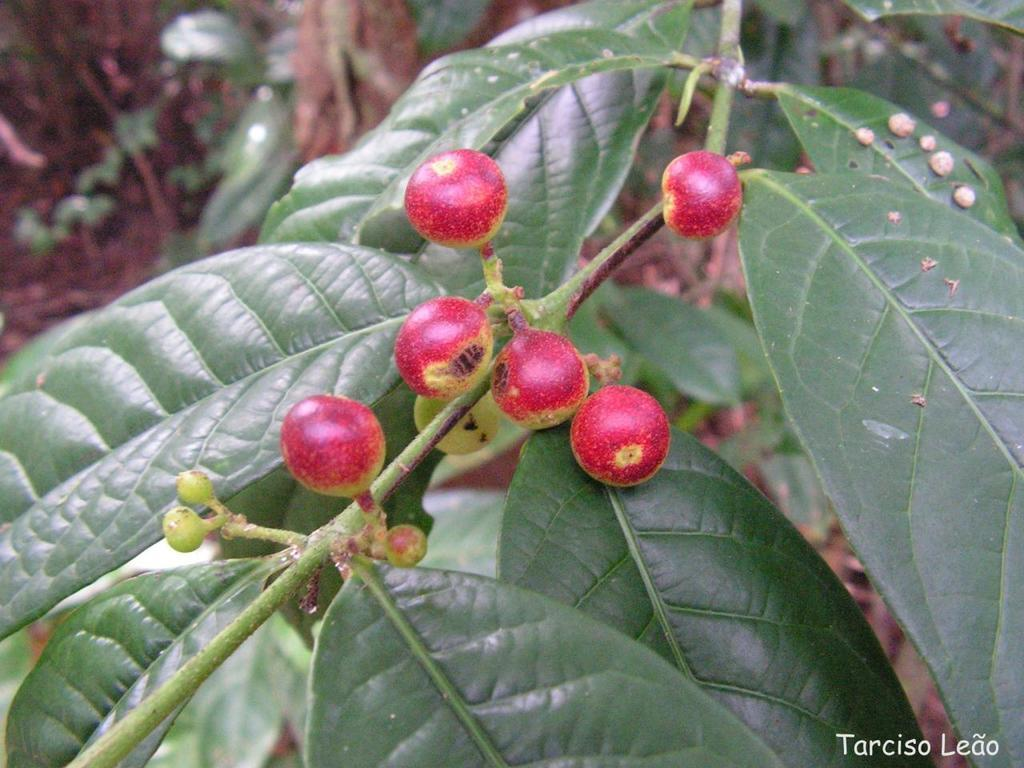What color are the fruits in the image? The fruits in the image are red. What color are the leaves in the image? The leaves in the image are green. What can be seen growing on the stem in the image? There are buds on a stem in the image. What is present at the top of the image? The top of the image contains mud. How does the daughter participate in the fight in the image? There is no daughter or fight present in the image. What type of seed can be seen growing in the image? There is no seed visible in the image; it only shows red fruits, green leaves, buds on a stem, and mud at the top. 